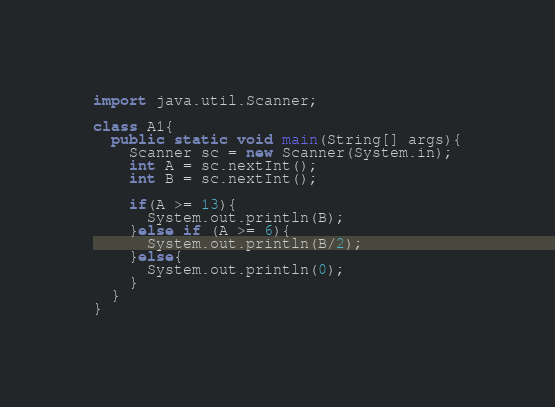<code> <loc_0><loc_0><loc_500><loc_500><_Java_>import java.util.Scanner;

class A1{
  public static void main(String[] args){
    Scanner sc = new Scanner(System.in);
    int A = sc.nextInt();
    int B = sc.nextInt();

    if(A >= 13){
      System.out.println(B);
    }else if (A >= 6){
      System.out.println(B/2);
    }else{
      System.out.println(0);
    }
  }
}
</code> 